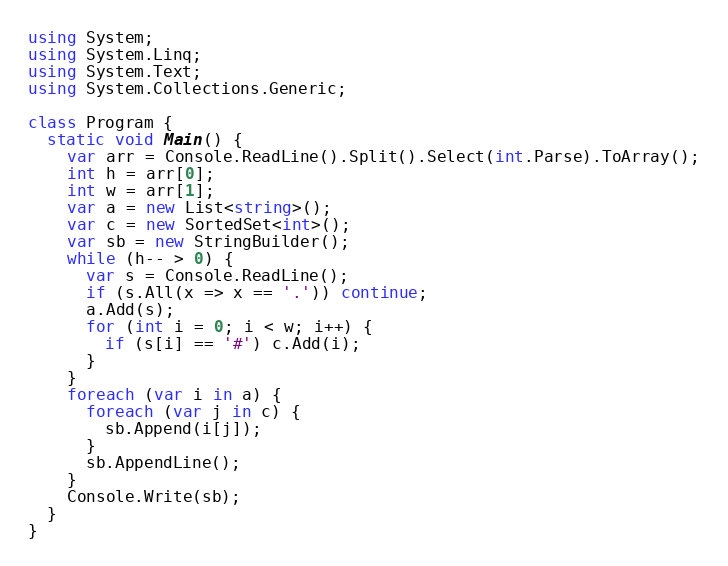Convert code to text. <code><loc_0><loc_0><loc_500><loc_500><_C#_>using System;
using System.Linq;
using System.Text;
using System.Collections.Generic;

class Program {
  static void Main() {
    var arr = Console.ReadLine().Split().Select(int.Parse).ToArray();
    int h = arr[0];
    int w = arr[1];
    var a = new List<string>();
    var c = new SortedSet<int>();
    var sb = new StringBuilder();
    while (h-- > 0) {
      var s = Console.ReadLine();
      if (s.All(x => x == '.')) continue;
      a.Add(s);
      for (int i = 0; i < w; i++) {
        if (s[i] == '#') c.Add(i);
      }
    }
    foreach (var i in a) {
      foreach (var j in c) {
        sb.Append(i[j]);
      }
      sb.AppendLine();
    }
    Console.Write(sb);
  }
}</code> 